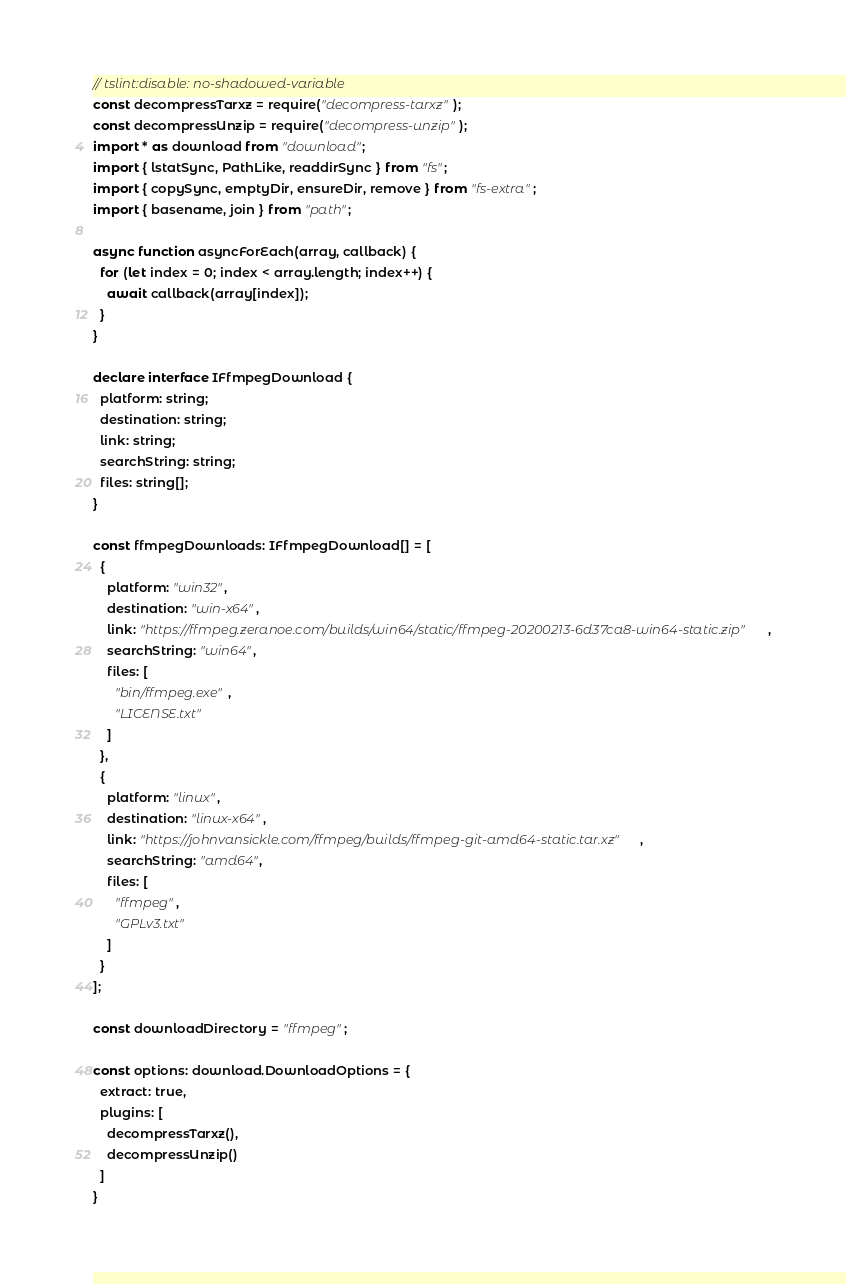<code> <loc_0><loc_0><loc_500><loc_500><_TypeScript_>// tslint:disable: no-shadowed-variable
const decompressTarxz = require("decompress-tarxz");
const decompressUnzip = require("decompress-unzip");
import * as download from "download";
import { lstatSync, PathLike, readdirSync } from "fs";
import { copySync, emptyDir, ensureDir, remove } from "fs-extra";
import { basename, join } from "path";

async function asyncForEach(array, callback) {
  for (let index = 0; index < array.length; index++) {
    await callback(array[index]);
  }
}

declare interface IFfmpegDownload {
  platform: string;
  destination: string;
  link: string;
  searchString: string;
  files: string[];
}

const ffmpegDownloads: IFfmpegDownload[] = [
  {
    platform: "win32",
    destination: "win-x64",
    link: "https://ffmpeg.zeranoe.com/builds/win64/static/ffmpeg-20200213-6d37ca8-win64-static.zip",
    searchString: "win64",
    files: [
      "bin/ffmpeg.exe",
      "LICENSE.txt"
    ]
  },
  {
    platform: "linux",
    destination: "linux-x64",
    link: "https://johnvansickle.com/ffmpeg/builds/ffmpeg-git-amd64-static.tar.xz",
    searchString: "amd64",
    files: [
      "ffmpeg",
      "GPLv3.txt"
    ]
  }
];

const downloadDirectory = "ffmpeg";

const options: download.DownloadOptions = {
  extract: true,
  plugins: [
    decompressTarxz(),
    decompressUnzip()
  ]
}
</code> 